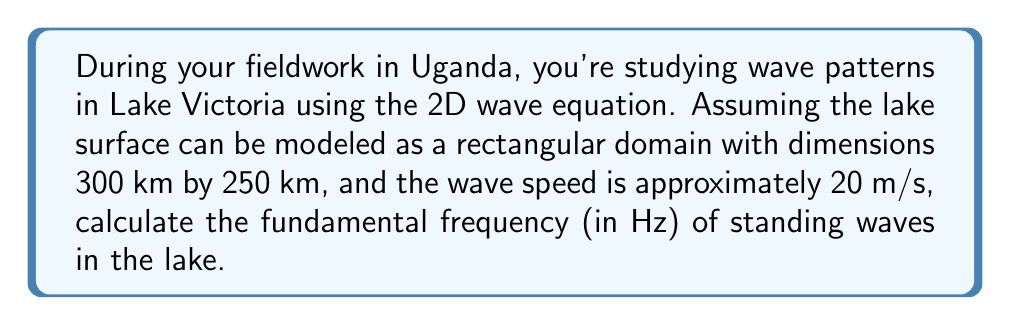Can you solve this math problem? To solve this problem, we'll follow these steps:

1) The 2D wave equation for standing waves in a rectangular domain is given by:

   $$\frac{\partial^2 u}{\partial t^2} = c^2 \left(\frac{\partial^2 u}{\partial x^2} + \frac{\partial^2 u}{\partial y^2}\right)$$

   where $c$ is the wave speed.

2) The solution for standing waves in a rectangular domain with dimensions $L_x$ and $L_y$ has the form:

   $$u(x,y,t) = A \sin(\frac{n\pi x}{L_x}) \sin(\frac{m\pi y}{L_y}) \cos(\omega t)$$

   where $n$ and $m$ are positive integers, and $\omega$ is the angular frequency.

3) Substituting this solution into the wave equation gives us the dispersion relation:

   $$\omega^2 = c^2 \left(\frac{n^2\pi^2}{L_x^2} + \frac{m^2\pi^2}{L_y^2}\right)$$

4) The fundamental frequency corresponds to $n=1$ and $m=1$. So we have:

   $$\omega^2 = c^2 \pi^2 \left(\frac{1}{L_x^2} + \frac{1}{L_y^2}\right)$$

5) We're given:
   $L_x = 300$ km $= 3 \times 10^5$ m
   $L_y = 250$ km $= 2.5 \times 10^5$ m
   $c = 20$ m/s

6) Substituting these values:

   $$\omega^2 = (20)^2 \pi^2 \left(\frac{1}{(3 \times 10^5)^2} + \frac{1}{(2.5 \times 10^5)^2}\right)$$

7) Simplifying:

   $$\omega^2 = 400 \pi^2 \left(\frac{1}{9 \times 10^{10}} + \frac{1}{6.25 \times 10^{10}}\right)$$
   $$\omega^2 = 400 \pi^2 \left(\frac{6.25 + 9}{56.25 \times 10^{10}}\right) = 400 \pi^2 \left(\frac{15.25}{56.25 \times 10^{10}}\right)$$

8) Calculate $\omega$:

   $$\omega = \sqrt{400 \pi^2 \frac{15.25}{56.25 \times 10^{10}}} \approx 0.000146 \text{ rad/s}$$

9) Convert angular frequency to frequency:

   $$f = \frac{\omega}{2\pi} \approx 2.32 \times 10^{-5} \text{ Hz}$$
Answer: $2.32 \times 10^{-5}$ Hz 